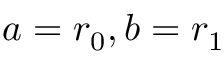<formula> <loc_0><loc_0><loc_500><loc_500>a = r _ { 0 } , b = r _ { 1 }</formula> 